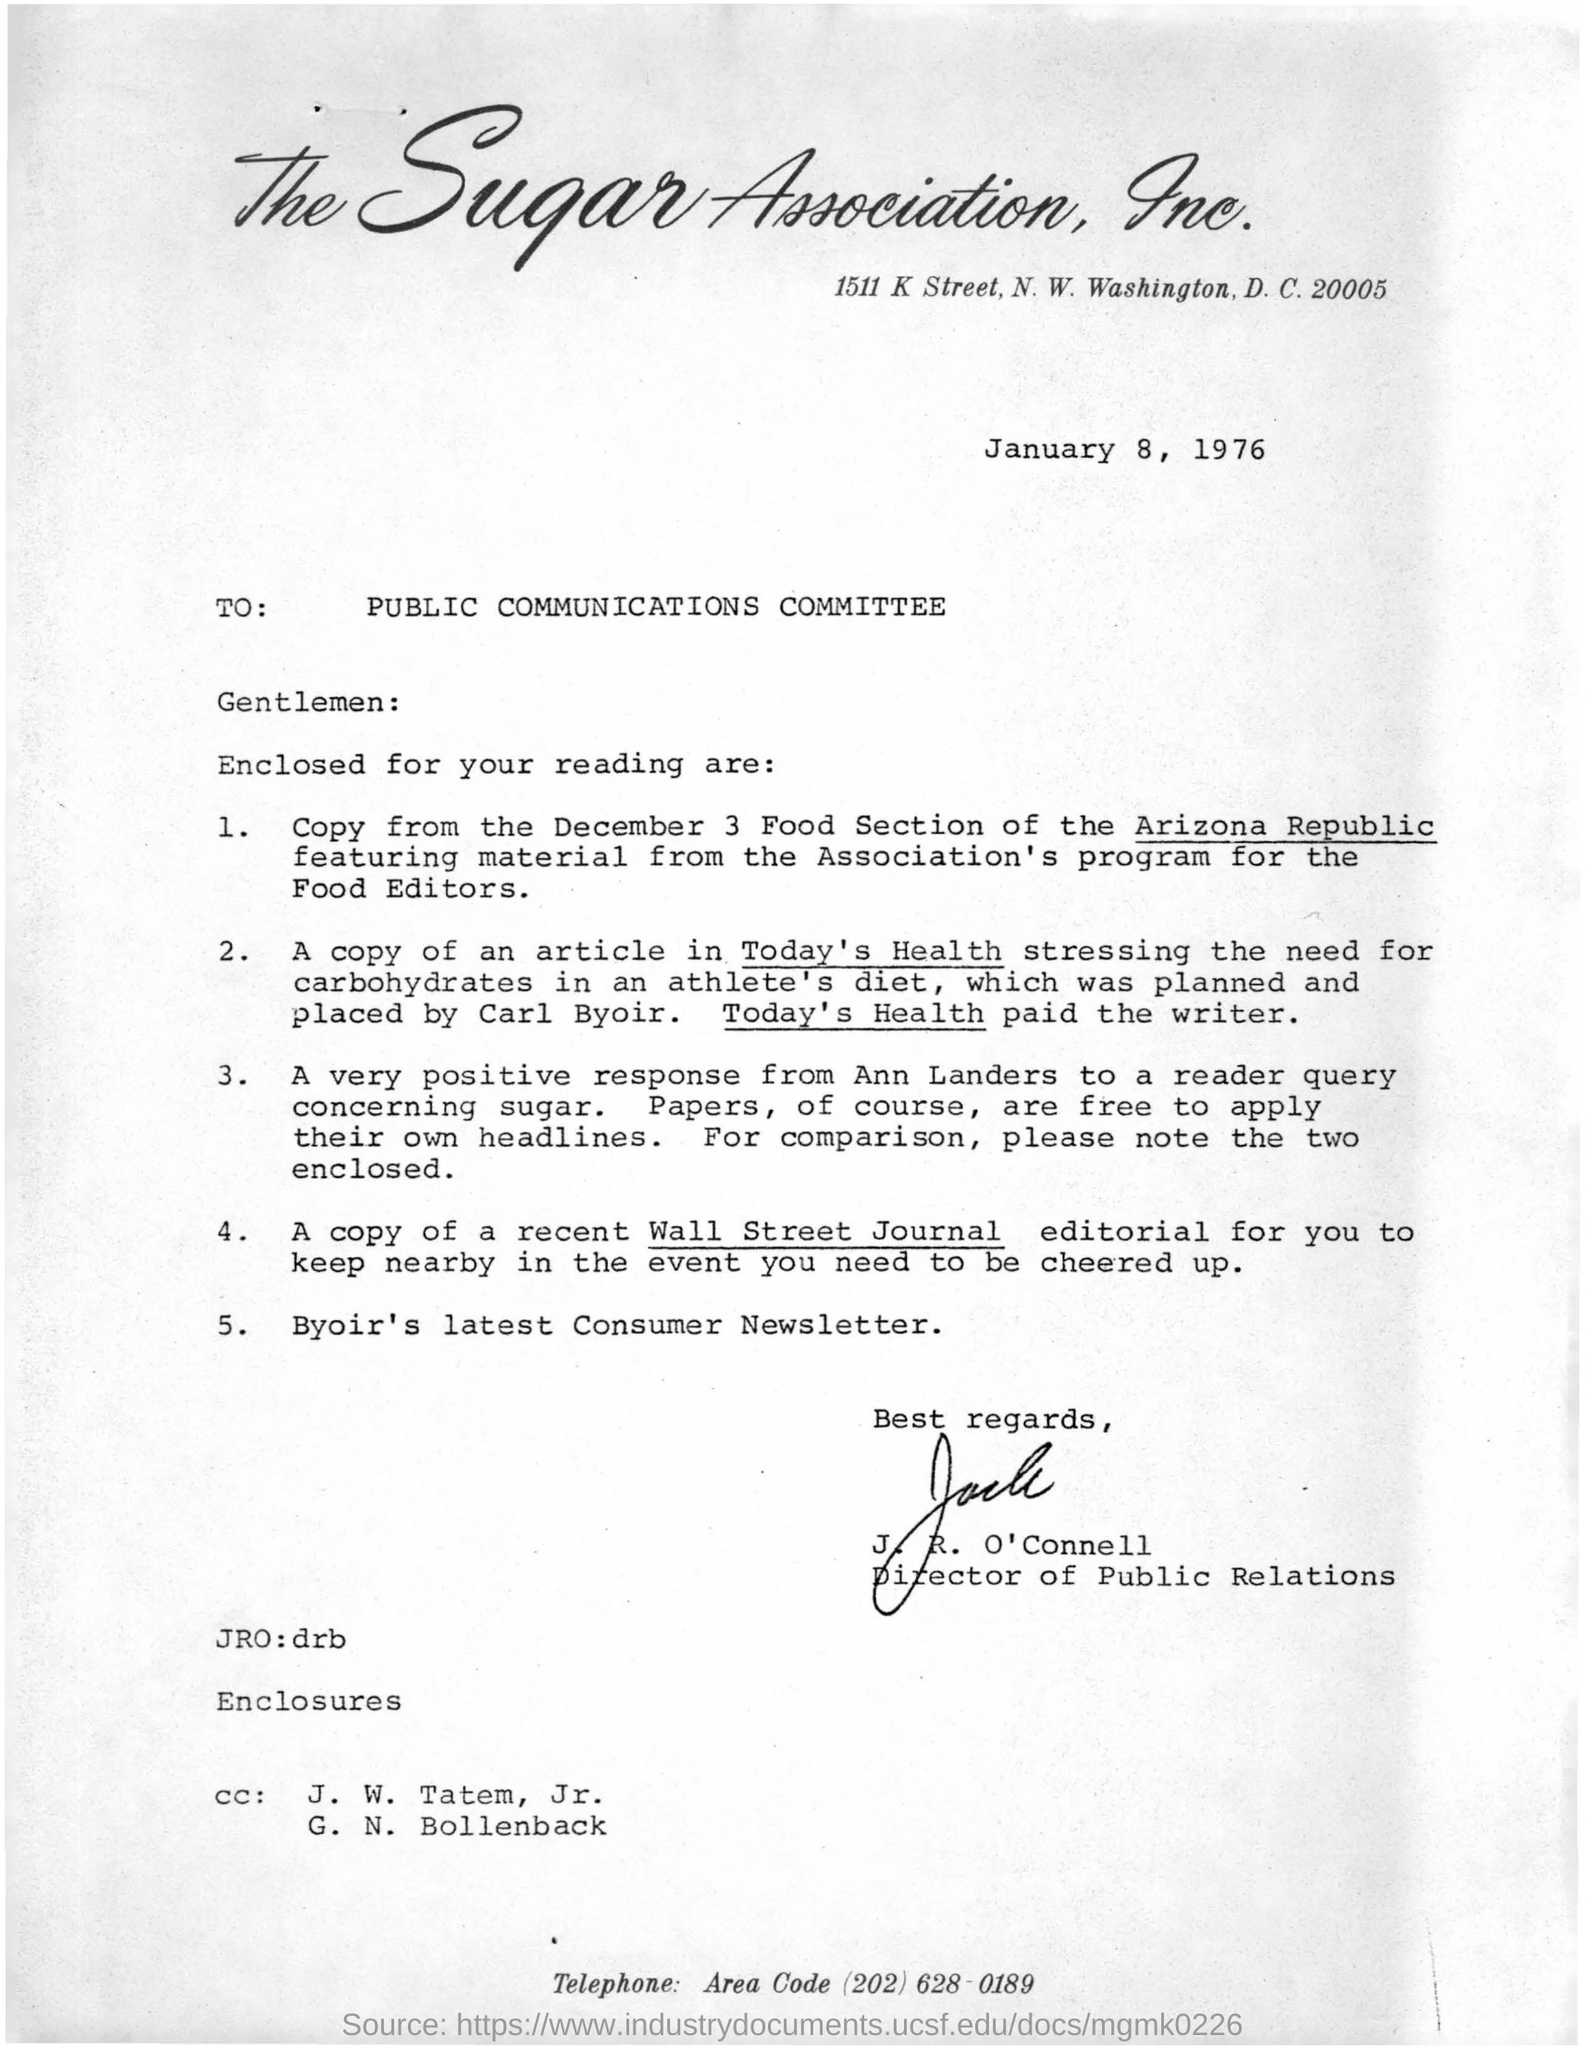Outline some significant characteristics in this image. The name of the association is the Sugar Association, Inc. John R. O'Connell signed the letter. The writer was paid by the person with today's health. 